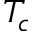<formula> <loc_0><loc_0><loc_500><loc_500>T _ { c }</formula> 